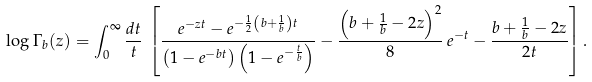<formula> <loc_0><loc_0><loc_500><loc_500>\log \Gamma _ { b } ( z ) = \int _ { 0 } ^ { \infty } \frac { d t } { t } \, \left [ \frac { e ^ { - z t } - e ^ { - \frac { 1 } { 2 } \left ( b + \frac { 1 } { b } \right ) t } } { \left ( 1 - e ^ { - b t } \right ) \left ( 1 - e ^ { - \frac { t } { b } } \right ) } - \frac { \left ( b + \frac { 1 } { b } - 2 z \right ) ^ { 2 } } { 8 } \, e ^ { - t } - \frac { b + \frac { 1 } { b } - 2 z } { 2 t } \right ] .</formula> 